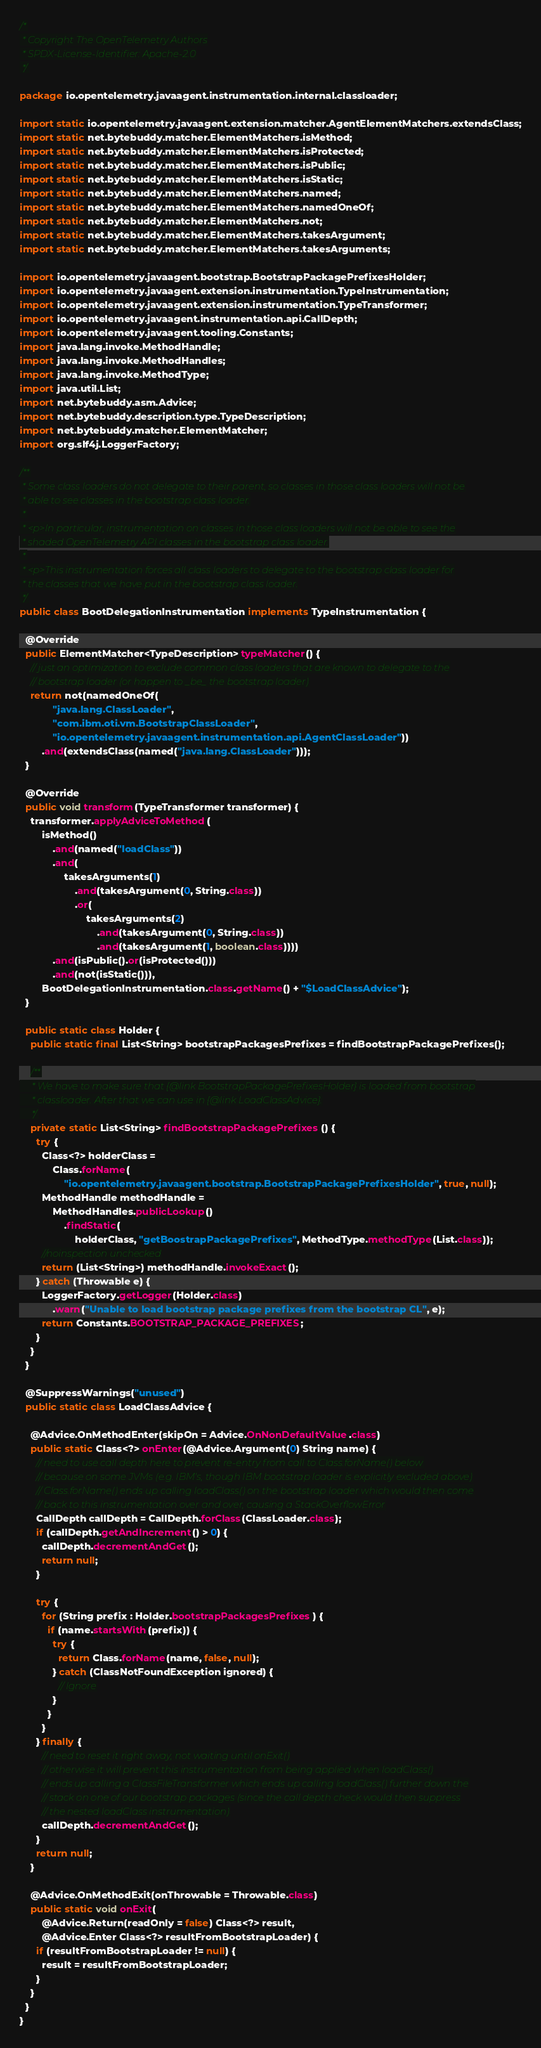Convert code to text. <code><loc_0><loc_0><loc_500><loc_500><_Java_>/*
 * Copyright The OpenTelemetry Authors
 * SPDX-License-Identifier: Apache-2.0
 */

package io.opentelemetry.javaagent.instrumentation.internal.classloader;

import static io.opentelemetry.javaagent.extension.matcher.AgentElementMatchers.extendsClass;
import static net.bytebuddy.matcher.ElementMatchers.isMethod;
import static net.bytebuddy.matcher.ElementMatchers.isProtected;
import static net.bytebuddy.matcher.ElementMatchers.isPublic;
import static net.bytebuddy.matcher.ElementMatchers.isStatic;
import static net.bytebuddy.matcher.ElementMatchers.named;
import static net.bytebuddy.matcher.ElementMatchers.namedOneOf;
import static net.bytebuddy.matcher.ElementMatchers.not;
import static net.bytebuddy.matcher.ElementMatchers.takesArgument;
import static net.bytebuddy.matcher.ElementMatchers.takesArguments;

import io.opentelemetry.javaagent.bootstrap.BootstrapPackagePrefixesHolder;
import io.opentelemetry.javaagent.extension.instrumentation.TypeInstrumentation;
import io.opentelemetry.javaagent.extension.instrumentation.TypeTransformer;
import io.opentelemetry.javaagent.instrumentation.api.CallDepth;
import io.opentelemetry.javaagent.tooling.Constants;
import java.lang.invoke.MethodHandle;
import java.lang.invoke.MethodHandles;
import java.lang.invoke.MethodType;
import java.util.List;
import net.bytebuddy.asm.Advice;
import net.bytebuddy.description.type.TypeDescription;
import net.bytebuddy.matcher.ElementMatcher;
import org.slf4j.LoggerFactory;

/**
 * Some class loaders do not delegate to their parent, so classes in those class loaders will not be
 * able to see classes in the bootstrap class loader.
 *
 * <p>In particular, instrumentation on classes in those class loaders will not be able to see the
 * shaded OpenTelemetry API classes in the bootstrap class loader.
 *
 * <p>This instrumentation forces all class loaders to delegate to the bootstrap class loader for
 * the classes that we have put in the bootstrap class loader.
 */
public class BootDelegationInstrumentation implements TypeInstrumentation {

  @Override
  public ElementMatcher<TypeDescription> typeMatcher() {
    // just an optimization to exclude common class loaders that are known to delegate to the
    // bootstrap loader (or happen to _be_ the bootstrap loader)
    return not(namedOneOf(
            "java.lang.ClassLoader",
            "com.ibm.oti.vm.BootstrapClassLoader",
            "io.opentelemetry.javaagent.instrumentation.api.AgentClassLoader"))
        .and(extendsClass(named("java.lang.ClassLoader")));
  }

  @Override
  public void transform(TypeTransformer transformer) {
    transformer.applyAdviceToMethod(
        isMethod()
            .and(named("loadClass"))
            .and(
                takesArguments(1)
                    .and(takesArgument(0, String.class))
                    .or(
                        takesArguments(2)
                            .and(takesArgument(0, String.class))
                            .and(takesArgument(1, boolean.class))))
            .and(isPublic().or(isProtected()))
            .and(not(isStatic())),
        BootDelegationInstrumentation.class.getName() + "$LoadClassAdvice");
  }

  public static class Holder {
    public static final List<String> bootstrapPackagesPrefixes = findBootstrapPackagePrefixes();

    /**
     * We have to make sure that {@link BootstrapPackagePrefixesHolder} is loaded from bootstrap
     * classloader. After that we can use in {@link LoadClassAdvice}.
     */
    private static List<String> findBootstrapPackagePrefixes() {
      try {
        Class<?> holderClass =
            Class.forName(
                "io.opentelemetry.javaagent.bootstrap.BootstrapPackagePrefixesHolder", true, null);
        MethodHandle methodHandle =
            MethodHandles.publicLookup()
                .findStatic(
                    holderClass, "getBoostrapPackagePrefixes", MethodType.methodType(List.class));
        //noinspection unchecked
        return (List<String>) methodHandle.invokeExact();
      } catch (Throwable e) {
        LoggerFactory.getLogger(Holder.class)
            .warn("Unable to load bootstrap package prefixes from the bootstrap CL", e);
        return Constants.BOOTSTRAP_PACKAGE_PREFIXES;
      }
    }
  }

  @SuppressWarnings("unused")
  public static class LoadClassAdvice {

    @Advice.OnMethodEnter(skipOn = Advice.OnNonDefaultValue.class)
    public static Class<?> onEnter(@Advice.Argument(0) String name) {
      // need to use call depth here to prevent re-entry from call to Class.forName() below
      // because on some JVMs (e.g. IBM's, though IBM bootstrap loader is explicitly excluded above)
      // Class.forName() ends up calling loadClass() on the bootstrap loader which would then come
      // back to this instrumentation over and over, causing a StackOverflowError
      CallDepth callDepth = CallDepth.forClass(ClassLoader.class);
      if (callDepth.getAndIncrement() > 0) {
        callDepth.decrementAndGet();
        return null;
      }

      try {
        for (String prefix : Holder.bootstrapPackagesPrefixes) {
          if (name.startsWith(prefix)) {
            try {
              return Class.forName(name, false, null);
            } catch (ClassNotFoundException ignored) {
              // Ignore
            }
          }
        }
      } finally {
        // need to reset it right away, not waiting until onExit()
        // otherwise it will prevent this instrumentation from being applied when loadClass()
        // ends up calling a ClassFileTransformer which ends up calling loadClass() further down the
        // stack on one of our bootstrap packages (since the call depth check would then suppress
        // the nested loadClass instrumentation)
        callDepth.decrementAndGet();
      }
      return null;
    }

    @Advice.OnMethodExit(onThrowable = Throwable.class)
    public static void onExit(
        @Advice.Return(readOnly = false) Class<?> result,
        @Advice.Enter Class<?> resultFromBootstrapLoader) {
      if (resultFromBootstrapLoader != null) {
        result = resultFromBootstrapLoader;
      }
    }
  }
}
</code> 